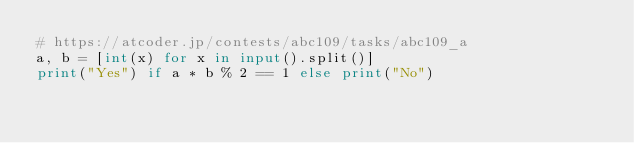<code> <loc_0><loc_0><loc_500><loc_500><_Python_># https://atcoder.jp/contests/abc109/tasks/abc109_a
a, b = [int(x) for x in input().split()]
print("Yes") if a * b % 2 == 1 else print("No")
</code> 